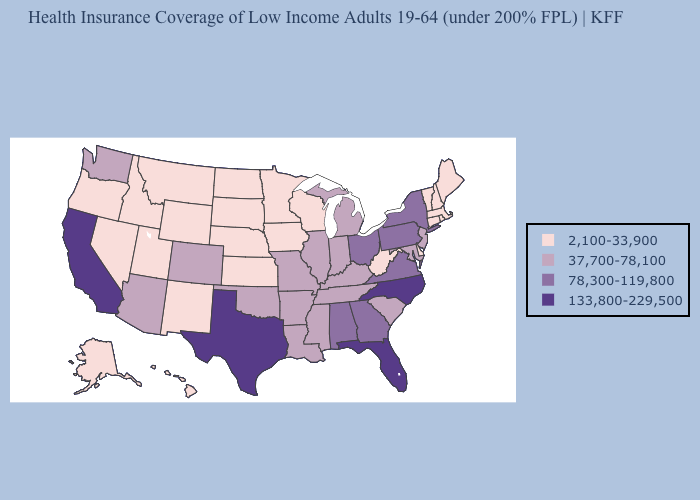What is the highest value in the South ?
Give a very brief answer. 133,800-229,500. Which states have the lowest value in the West?
Concise answer only. Alaska, Hawaii, Idaho, Montana, Nevada, New Mexico, Oregon, Utah, Wyoming. How many symbols are there in the legend?
Keep it brief. 4. Does New Jersey have the lowest value in the Northeast?
Concise answer only. No. Does Mississippi have the lowest value in the USA?
Give a very brief answer. No. Does Indiana have the lowest value in the MidWest?
Keep it brief. No. What is the value of Kentucky?
Answer briefly. 37,700-78,100. Does West Virginia have the lowest value in the South?
Answer briefly. Yes. Name the states that have a value in the range 133,800-229,500?
Answer briefly. California, Florida, North Carolina, Texas. Among the states that border Georgia , which have the lowest value?
Write a very short answer. South Carolina, Tennessee. Which states have the lowest value in the USA?
Write a very short answer. Alaska, Connecticut, Delaware, Hawaii, Idaho, Iowa, Kansas, Maine, Massachusetts, Minnesota, Montana, Nebraska, Nevada, New Hampshire, New Mexico, North Dakota, Oregon, Rhode Island, South Dakota, Utah, Vermont, West Virginia, Wisconsin, Wyoming. What is the value of Kansas?
Be succinct. 2,100-33,900. What is the lowest value in the USA?
Answer briefly. 2,100-33,900. What is the value of Missouri?
Keep it brief. 37,700-78,100. 